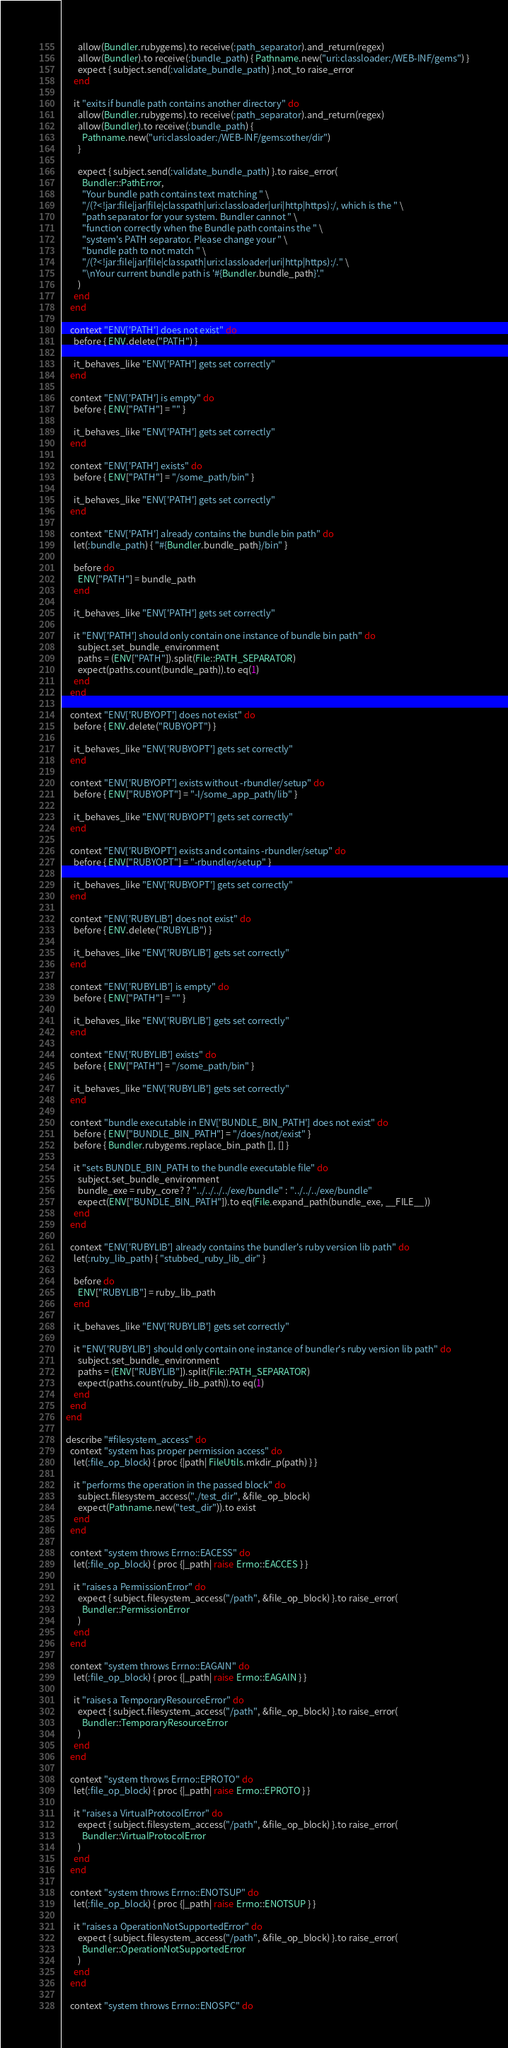<code> <loc_0><loc_0><loc_500><loc_500><_Ruby_>        allow(Bundler.rubygems).to receive(:path_separator).and_return(regex)
        allow(Bundler).to receive(:bundle_path) { Pathname.new("uri:classloader:/WEB-INF/gems") }
        expect { subject.send(:validate_bundle_path) }.not_to raise_error
      end

      it "exits if bundle path contains another directory" do
        allow(Bundler.rubygems).to receive(:path_separator).and_return(regex)
        allow(Bundler).to receive(:bundle_path) {
          Pathname.new("uri:classloader:/WEB-INF/gems:other/dir")
        }

        expect { subject.send(:validate_bundle_path) }.to raise_error(
          Bundler::PathError,
          "Your bundle path contains text matching " \
          "/(?<!jar:file|jar|file|classpath|uri:classloader|uri|http|https):/, which is the " \
          "path separator for your system. Bundler cannot " \
          "function correctly when the Bundle path contains the " \
          "system's PATH separator. Please change your " \
          "bundle path to not match " \
          "/(?<!jar:file|jar|file|classpath|uri:classloader|uri|http|https):/." \
          "\nYour current bundle path is '#{Bundler.bundle_path}'."
        )
      end
    end

    context "ENV['PATH'] does not exist" do
      before { ENV.delete("PATH") }

      it_behaves_like "ENV['PATH'] gets set correctly"
    end

    context "ENV['PATH'] is empty" do
      before { ENV["PATH"] = "" }

      it_behaves_like "ENV['PATH'] gets set correctly"
    end

    context "ENV['PATH'] exists" do
      before { ENV["PATH"] = "/some_path/bin" }

      it_behaves_like "ENV['PATH'] gets set correctly"
    end

    context "ENV['PATH'] already contains the bundle bin path" do
      let(:bundle_path) { "#{Bundler.bundle_path}/bin" }

      before do
        ENV["PATH"] = bundle_path
      end

      it_behaves_like "ENV['PATH'] gets set correctly"

      it "ENV['PATH'] should only contain one instance of bundle bin path" do
        subject.set_bundle_environment
        paths = (ENV["PATH"]).split(File::PATH_SEPARATOR)
        expect(paths.count(bundle_path)).to eq(1)
      end
    end

    context "ENV['RUBYOPT'] does not exist" do
      before { ENV.delete("RUBYOPT") }

      it_behaves_like "ENV['RUBYOPT'] gets set correctly"
    end

    context "ENV['RUBYOPT'] exists without -rbundler/setup" do
      before { ENV["RUBYOPT"] = "-I/some_app_path/lib" }

      it_behaves_like "ENV['RUBYOPT'] gets set correctly"
    end

    context "ENV['RUBYOPT'] exists and contains -rbundler/setup" do
      before { ENV["RUBYOPT"] = "-rbundler/setup" }

      it_behaves_like "ENV['RUBYOPT'] gets set correctly"
    end

    context "ENV['RUBYLIB'] does not exist" do
      before { ENV.delete("RUBYLIB") }

      it_behaves_like "ENV['RUBYLIB'] gets set correctly"
    end

    context "ENV['RUBYLIB'] is empty" do
      before { ENV["PATH"] = "" }

      it_behaves_like "ENV['RUBYLIB'] gets set correctly"
    end

    context "ENV['RUBYLIB'] exists" do
      before { ENV["PATH"] = "/some_path/bin" }

      it_behaves_like "ENV['RUBYLIB'] gets set correctly"
    end

    context "bundle executable in ENV['BUNDLE_BIN_PATH'] does not exist" do
      before { ENV["BUNDLE_BIN_PATH"] = "/does/not/exist" }
      before { Bundler.rubygems.replace_bin_path [], [] }

      it "sets BUNDLE_BIN_PATH to the bundle executable file" do
        subject.set_bundle_environment
        bundle_exe = ruby_core? ? "../../../../exe/bundle" : "../../../exe/bundle"
        expect(ENV["BUNDLE_BIN_PATH"]).to eq(File.expand_path(bundle_exe, __FILE__))
      end
    end

    context "ENV['RUBYLIB'] already contains the bundler's ruby version lib path" do
      let(:ruby_lib_path) { "stubbed_ruby_lib_dir" }

      before do
        ENV["RUBYLIB"] = ruby_lib_path
      end

      it_behaves_like "ENV['RUBYLIB'] gets set correctly"

      it "ENV['RUBYLIB'] should only contain one instance of bundler's ruby version lib path" do
        subject.set_bundle_environment
        paths = (ENV["RUBYLIB"]).split(File::PATH_SEPARATOR)
        expect(paths.count(ruby_lib_path)).to eq(1)
      end
    end
  end

  describe "#filesystem_access" do
    context "system has proper permission access" do
      let(:file_op_block) { proc {|path| FileUtils.mkdir_p(path) } }

      it "performs the operation in the passed block" do
        subject.filesystem_access("./test_dir", &file_op_block)
        expect(Pathname.new("test_dir")).to exist
      end
    end

    context "system throws Errno::EACESS" do
      let(:file_op_block) { proc {|_path| raise Errno::EACCES } }

      it "raises a PermissionError" do
        expect { subject.filesystem_access("/path", &file_op_block) }.to raise_error(
          Bundler::PermissionError
        )
      end
    end

    context "system throws Errno::EAGAIN" do
      let(:file_op_block) { proc {|_path| raise Errno::EAGAIN } }

      it "raises a TemporaryResourceError" do
        expect { subject.filesystem_access("/path", &file_op_block) }.to raise_error(
          Bundler::TemporaryResourceError
        )
      end
    end

    context "system throws Errno::EPROTO" do
      let(:file_op_block) { proc {|_path| raise Errno::EPROTO } }

      it "raises a VirtualProtocolError" do
        expect { subject.filesystem_access("/path", &file_op_block) }.to raise_error(
          Bundler::VirtualProtocolError
        )
      end
    end

    context "system throws Errno::ENOTSUP" do
      let(:file_op_block) { proc {|_path| raise Errno::ENOTSUP } }

      it "raises a OperationNotSupportedError" do
        expect { subject.filesystem_access("/path", &file_op_block) }.to raise_error(
          Bundler::OperationNotSupportedError
        )
      end
    end

    context "system throws Errno::ENOSPC" do</code> 